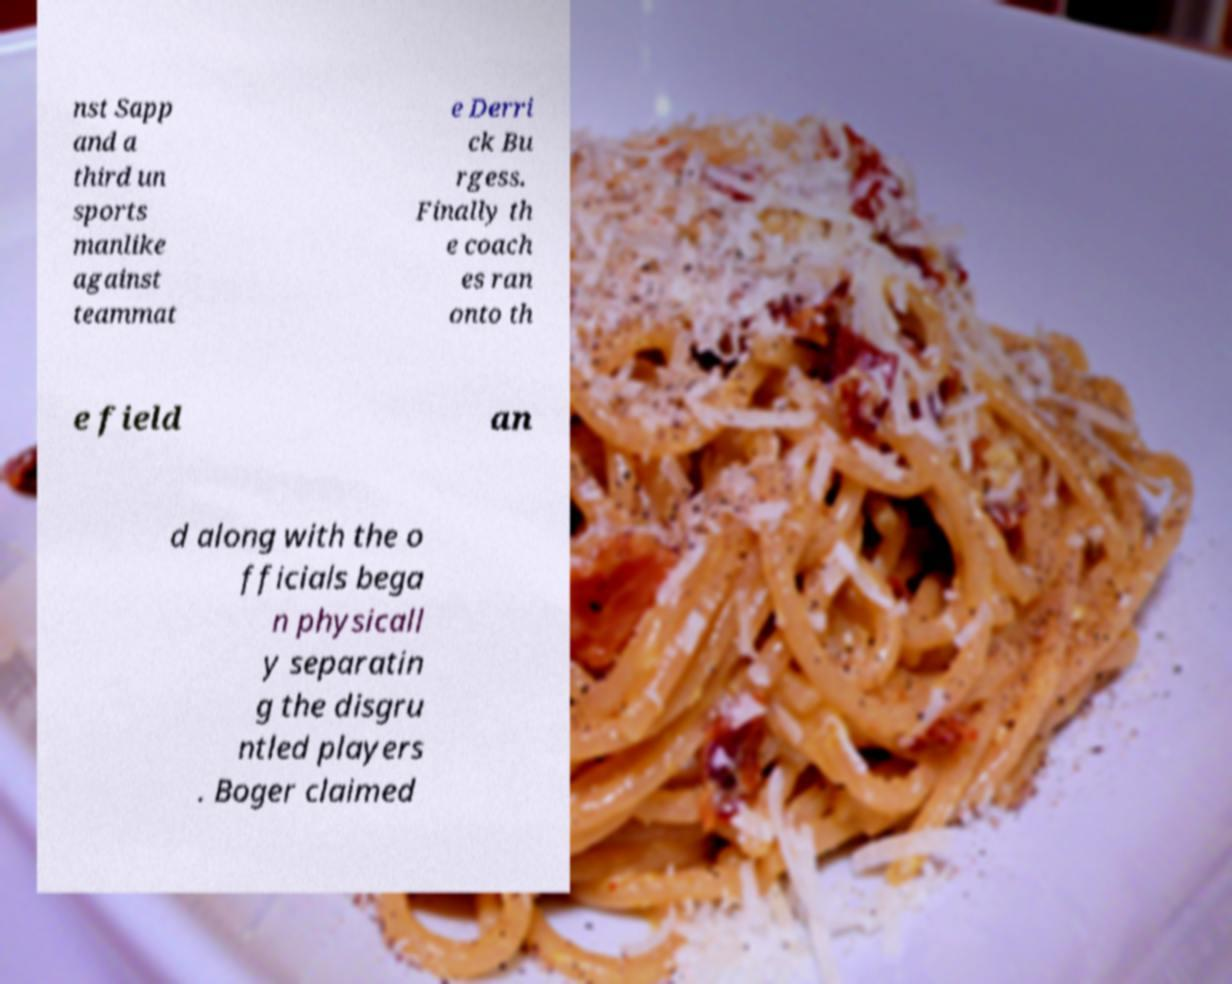Can you accurately transcribe the text from the provided image for me? nst Sapp and a third un sports manlike against teammat e Derri ck Bu rgess. Finally th e coach es ran onto th e field an d along with the o fficials bega n physicall y separatin g the disgru ntled players . Boger claimed 